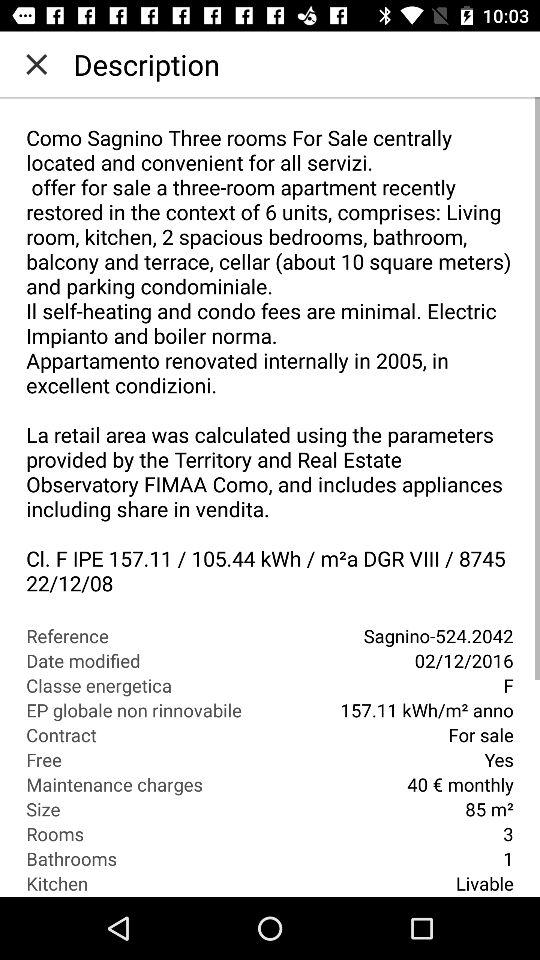How many bathrooms are shown? The number of bathrooms shown is 1. 